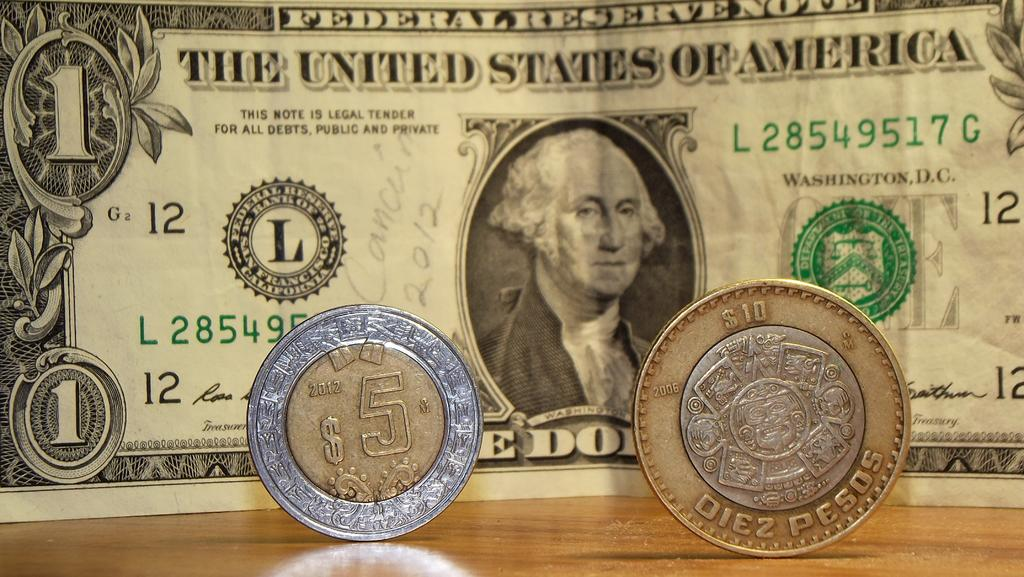<image>
Offer a succinct explanation of the picture presented. a one dollar bill behind two coins with one that says $5 on it 